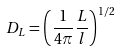<formula> <loc_0><loc_0><loc_500><loc_500>D _ { L } = \left ( \frac { 1 } { 4 \pi } \frac { L } { l } \right ) ^ { 1 / 2 }</formula> 